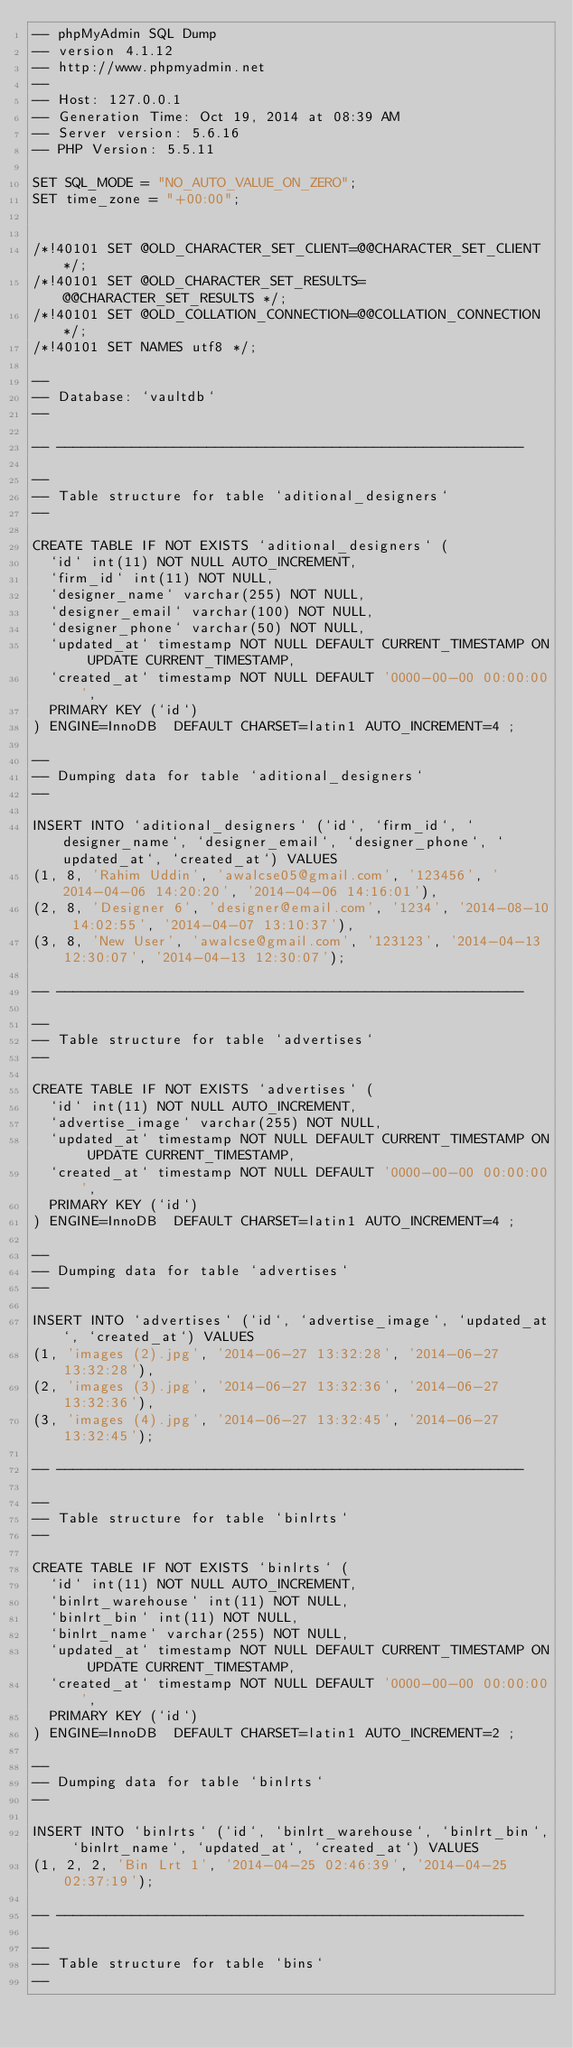Convert code to text. <code><loc_0><loc_0><loc_500><loc_500><_SQL_>-- phpMyAdmin SQL Dump
-- version 4.1.12
-- http://www.phpmyadmin.net
--
-- Host: 127.0.0.1
-- Generation Time: Oct 19, 2014 at 08:39 AM
-- Server version: 5.6.16
-- PHP Version: 5.5.11

SET SQL_MODE = "NO_AUTO_VALUE_ON_ZERO";
SET time_zone = "+00:00";


/*!40101 SET @OLD_CHARACTER_SET_CLIENT=@@CHARACTER_SET_CLIENT */;
/*!40101 SET @OLD_CHARACTER_SET_RESULTS=@@CHARACTER_SET_RESULTS */;
/*!40101 SET @OLD_COLLATION_CONNECTION=@@COLLATION_CONNECTION */;
/*!40101 SET NAMES utf8 */;

--
-- Database: `vaultdb`
--

-- --------------------------------------------------------

--
-- Table structure for table `aditional_designers`
--

CREATE TABLE IF NOT EXISTS `aditional_designers` (
  `id` int(11) NOT NULL AUTO_INCREMENT,
  `firm_id` int(11) NOT NULL,
  `designer_name` varchar(255) NOT NULL,
  `designer_email` varchar(100) NOT NULL,
  `designer_phone` varchar(50) NOT NULL,
  `updated_at` timestamp NOT NULL DEFAULT CURRENT_TIMESTAMP ON UPDATE CURRENT_TIMESTAMP,
  `created_at` timestamp NOT NULL DEFAULT '0000-00-00 00:00:00',
  PRIMARY KEY (`id`)
) ENGINE=InnoDB  DEFAULT CHARSET=latin1 AUTO_INCREMENT=4 ;

--
-- Dumping data for table `aditional_designers`
--

INSERT INTO `aditional_designers` (`id`, `firm_id`, `designer_name`, `designer_email`, `designer_phone`, `updated_at`, `created_at`) VALUES
(1, 8, 'Rahim Uddin', 'awalcse05@gmail.com', '123456', '2014-04-06 14:20:20', '2014-04-06 14:16:01'),
(2, 8, 'Designer 6', 'designer@email.com', '1234', '2014-08-10 14:02:55', '2014-04-07 13:10:37'),
(3, 8, 'New User', 'awalcse@gmail.com', '123123', '2014-04-13 12:30:07', '2014-04-13 12:30:07');

-- --------------------------------------------------------

--
-- Table structure for table `advertises`
--

CREATE TABLE IF NOT EXISTS `advertises` (
  `id` int(11) NOT NULL AUTO_INCREMENT,
  `advertise_image` varchar(255) NOT NULL,
  `updated_at` timestamp NOT NULL DEFAULT CURRENT_TIMESTAMP ON UPDATE CURRENT_TIMESTAMP,
  `created_at` timestamp NOT NULL DEFAULT '0000-00-00 00:00:00',
  PRIMARY KEY (`id`)
) ENGINE=InnoDB  DEFAULT CHARSET=latin1 AUTO_INCREMENT=4 ;

--
-- Dumping data for table `advertises`
--

INSERT INTO `advertises` (`id`, `advertise_image`, `updated_at`, `created_at`) VALUES
(1, 'images (2).jpg', '2014-06-27 13:32:28', '2014-06-27 13:32:28'),
(2, 'images (3).jpg', '2014-06-27 13:32:36', '2014-06-27 13:32:36'),
(3, 'images (4).jpg', '2014-06-27 13:32:45', '2014-06-27 13:32:45');

-- --------------------------------------------------------

--
-- Table structure for table `binlrts`
--

CREATE TABLE IF NOT EXISTS `binlrts` (
  `id` int(11) NOT NULL AUTO_INCREMENT,
  `binlrt_warehouse` int(11) NOT NULL,
  `binlrt_bin` int(11) NOT NULL,
  `binlrt_name` varchar(255) NOT NULL,
  `updated_at` timestamp NOT NULL DEFAULT CURRENT_TIMESTAMP ON UPDATE CURRENT_TIMESTAMP,
  `created_at` timestamp NOT NULL DEFAULT '0000-00-00 00:00:00',
  PRIMARY KEY (`id`)
) ENGINE=InnoDB  DEFAULT CHARSET=latin1 AUTO_INCREMENT=2 ;

--
-- Dumping data for table `binlrts`
--

INSERT INTO `binlrts` (`id`, `binlrt_warehouse`, `binlrt_bin`, `binlrt_name`, `updated_at`, `created_at`) VALUES
(1, 2, 2, 'Bin Lrt 1', '2014-04-25 02:46:39', '2014-04-25 02:37:19');

-- --------------------------------------------------------

--
-- Table structure for table `bins`
--
</code> 